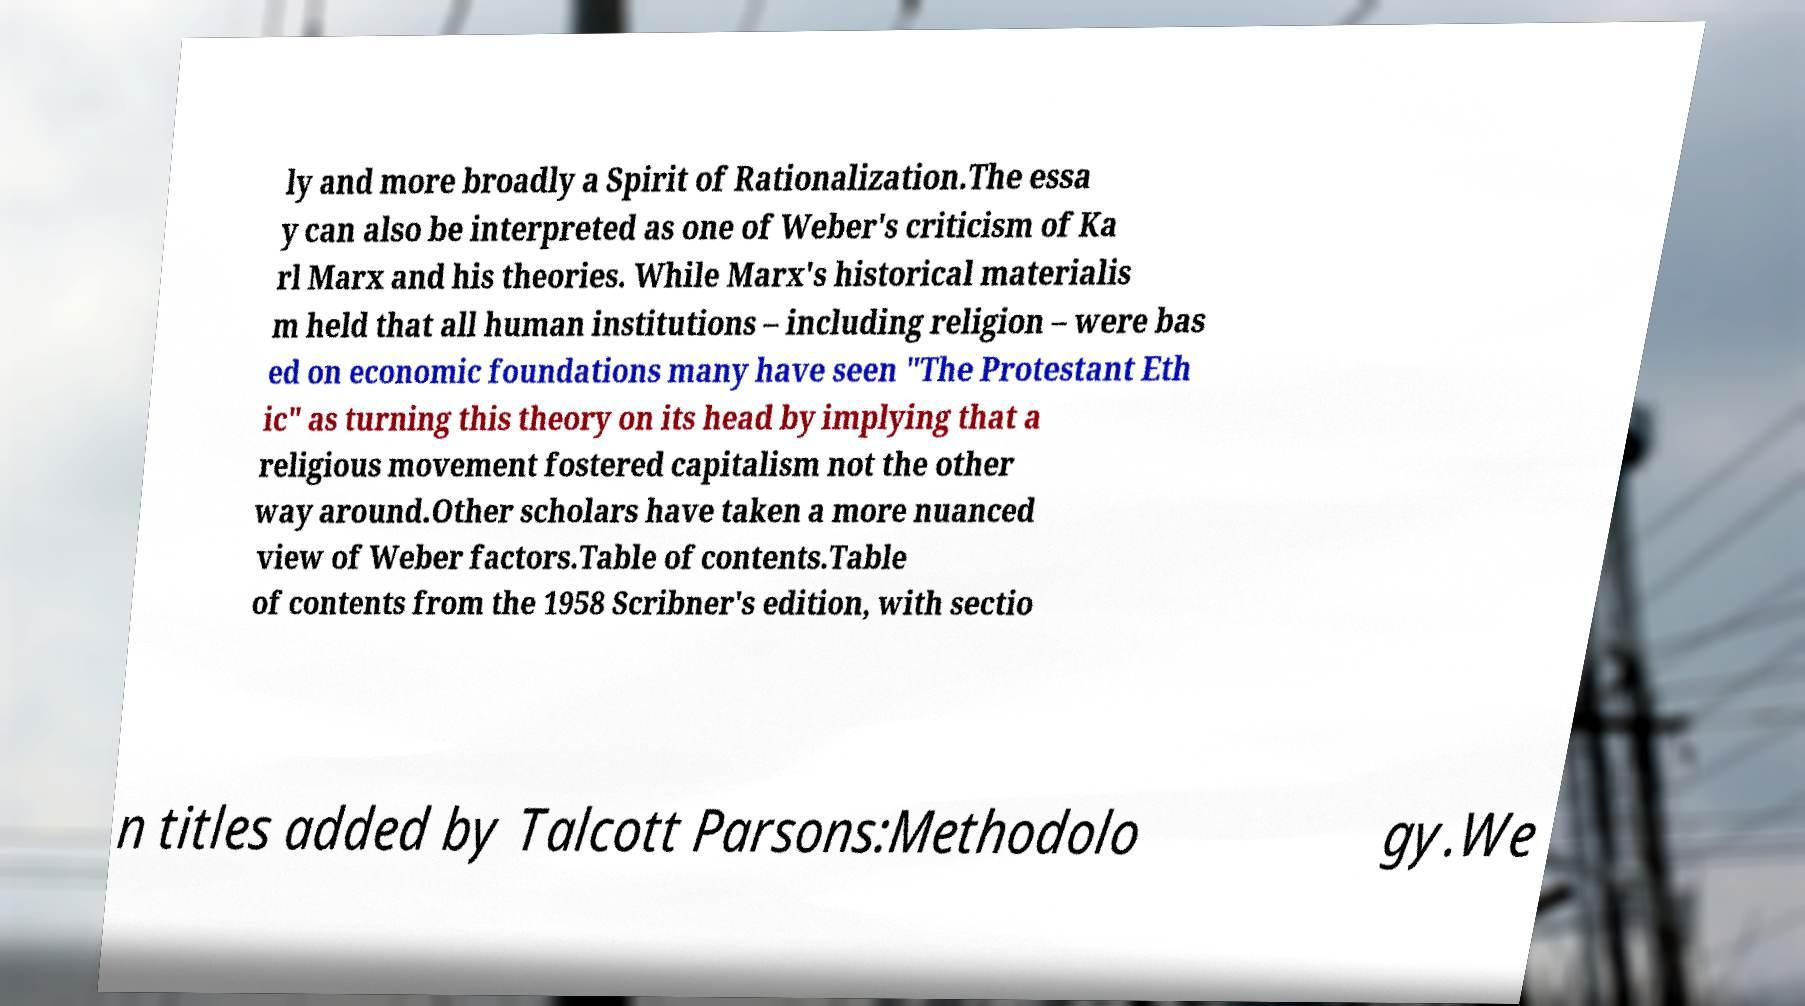Can you accurately transcribe the text from the provided image for me? ly and more broadly a Spirit of Rationalization.The essa y can also be interpreted as one of Weber's criticism of Ka rl Marx and his theories. While Marx's historical materialis m held that all human institutions – including religion – were bas ed on economic foundations many have seen "The Protestant Eth ic" as turning this theory on its head by implying that a religious movement fostered capitalism not the other way around.Other scholars have taken a more nuanced view of Weber factors.Table of contents.Table of contents from the 1958 Scribner's edition, with sectio n titles added by Talcott Parsons:Methodolo gy.We 